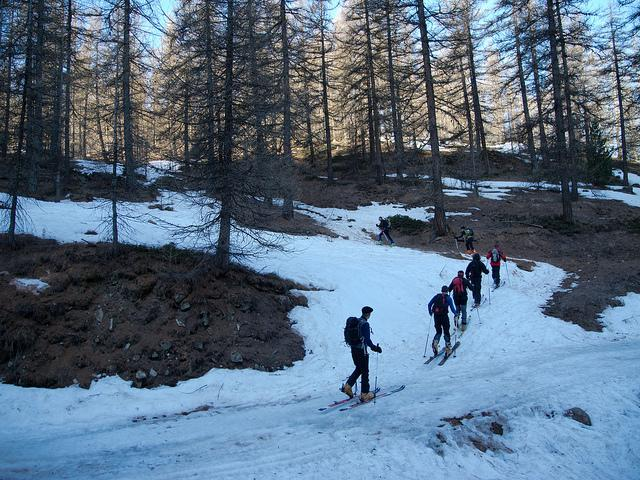Why are they skiing on level ground? Please explain your reasoning. cross-country. The people are going across the country. 